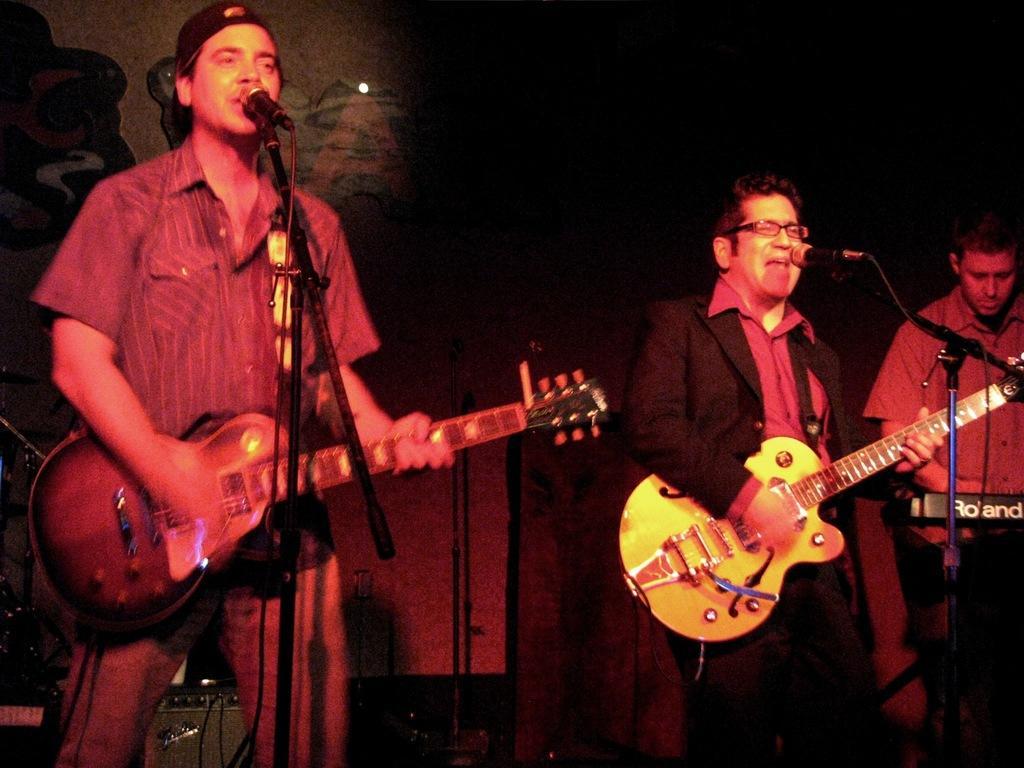Can you describe this image briefly? Here we can see three people standing and two guys are playing guitar and singing song in the microphone present in front of them and the guy at the right side is playing his key board 